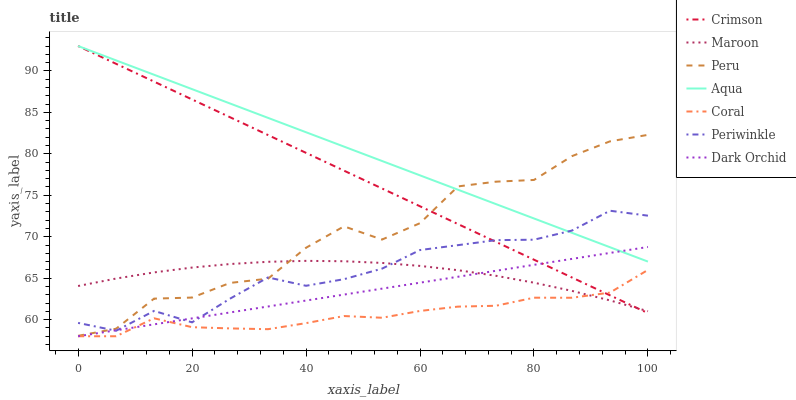Does Coral have the minimum area under the curve?
Answer yes or no. Yes. Does Aqua have the maximum area under the curve?
Answer yes or no. Yes. Does Maroon have the minimum area under the curve?
Answer yes or no. No. Does Maroon have the maximum area under the curve?
Answer yes or no. No. Is Crimson the smoothest?
Answer yes or no. Yes. Is Peru the roughest?
Answer yes or no. Yes. Is Aqua the smoothest?
Answer yes or no. No. Is Aqua the roughest?
Answer yes or no. No. Does Coral have the lowest value?
Answer yes or no. Yes. Does Maroon have the lowest value?
Answer yes or no. No. Does Crimson have the highest value?
Answer yes or no. Yes. Does Maroon have the highest value?
Answer yes or no. No. Is Coral less than Periwinkle?
Answer yes or no. Yes. Is Aqua greater than Coral?
Answer yes or no. Yes. Does Peru intersect Crimson?
Answer yes or no. Yes. Is Peru less than Crimson?
Answer yes or no. No. Is Peru greater than Crimson?
Answer yes or no. No. Does Coral intersect Periwinkle?
Answer yes or no. No. 